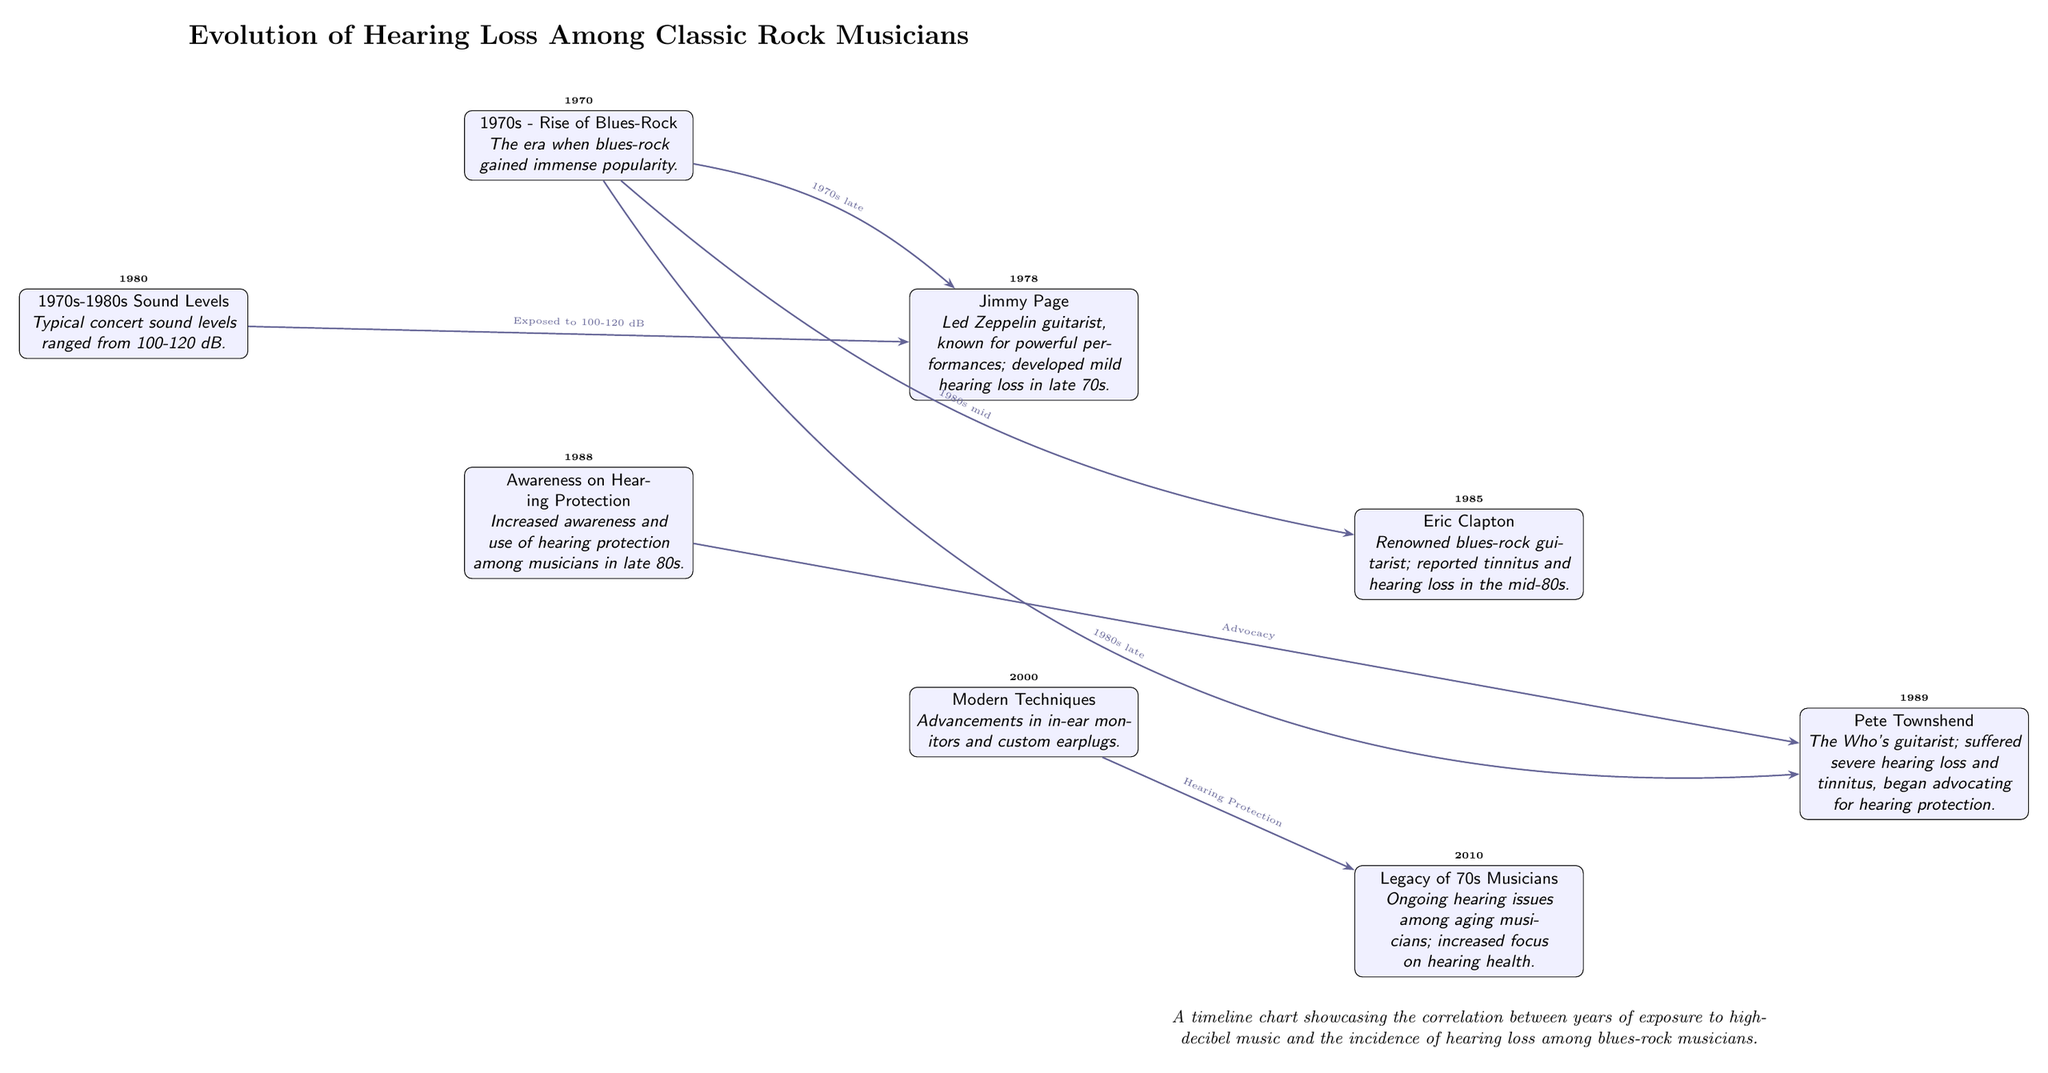What decade is marked as the rise of blues-rock? The diagram states that the rise of blues-rock occurred in the 1970s, as indicated in the first node.
Answer: 1970s Who is noted for developing mild hearing loss in the late 70s? The second node indicates that Jimmy Page, the Led Zeppelin guitarist, developed mild hearing loss in the late 70s.
Answer: Jimmy Page What was the typical concert sound level range in the 1980s? The diagram specifies that typical concert sound levels during this period ranged from 100-120 dB in the fifth node.
Answer: 100-120 dB What significant change in awareness occurred in the late 80s? The sixth node mentions that there was increased awareness and use of hearing protection among musicians in the late 80s.
Answer: Awareness on Hearing Protection Which musician advocated for hearing protection due to suffering severe hearing loss? The fourth node describes Pete Townshend from The Who suffering severe hearing loss and later advocating for hearing protection.
Answer: Pete Townshend What correlation is illustrated in the timeline? The timeline illustrates the correlation between years of exposure to high-decibel music and the incidence of hearing loss among blues-rock musicians.
Answer: Correlation between exposure and hearing loss What modern techniques are mentioned in relation to musicians' hearing health? The seventh node points out advancements in in-ear monitors and custom earplugs as modern techniques for hearing health.
Answer: Modern Techniques In what year did Eric Clapton report tinnitus and hearing loss? According to the third node, Eric Clapton reported tinnitus and hearing loss in the mid-1980s, which is marked as 1985 in the timeline.
Answer: 1985 What is the significant ongoing issue noted regarding aging musicians? The last node highlights ongoing hearing issues among aging musicians and an increased focus on hearing health.
Answer: Ongoing hearing issues 